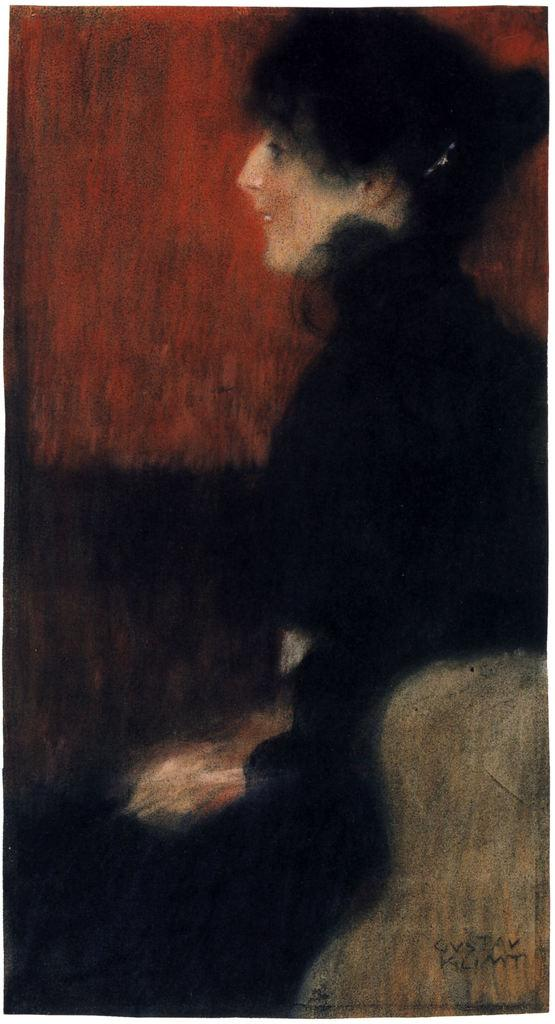What is the main subject of the image? There is a painting in the image. What is the painting depicting? The painting depicts a woman. What is the woman wearing in the painting? The woman is wearing black clothes. How many clocks are hanging on the wall behind the woman in the painting? There are no clocks visible in the painting; it only depicts a woman wearing black clothes. Can you tell me how many jellyfish are swimming in the background of the painting? There are no jellyfish present in the painting; it only depicts a woman wearing black clothes. 